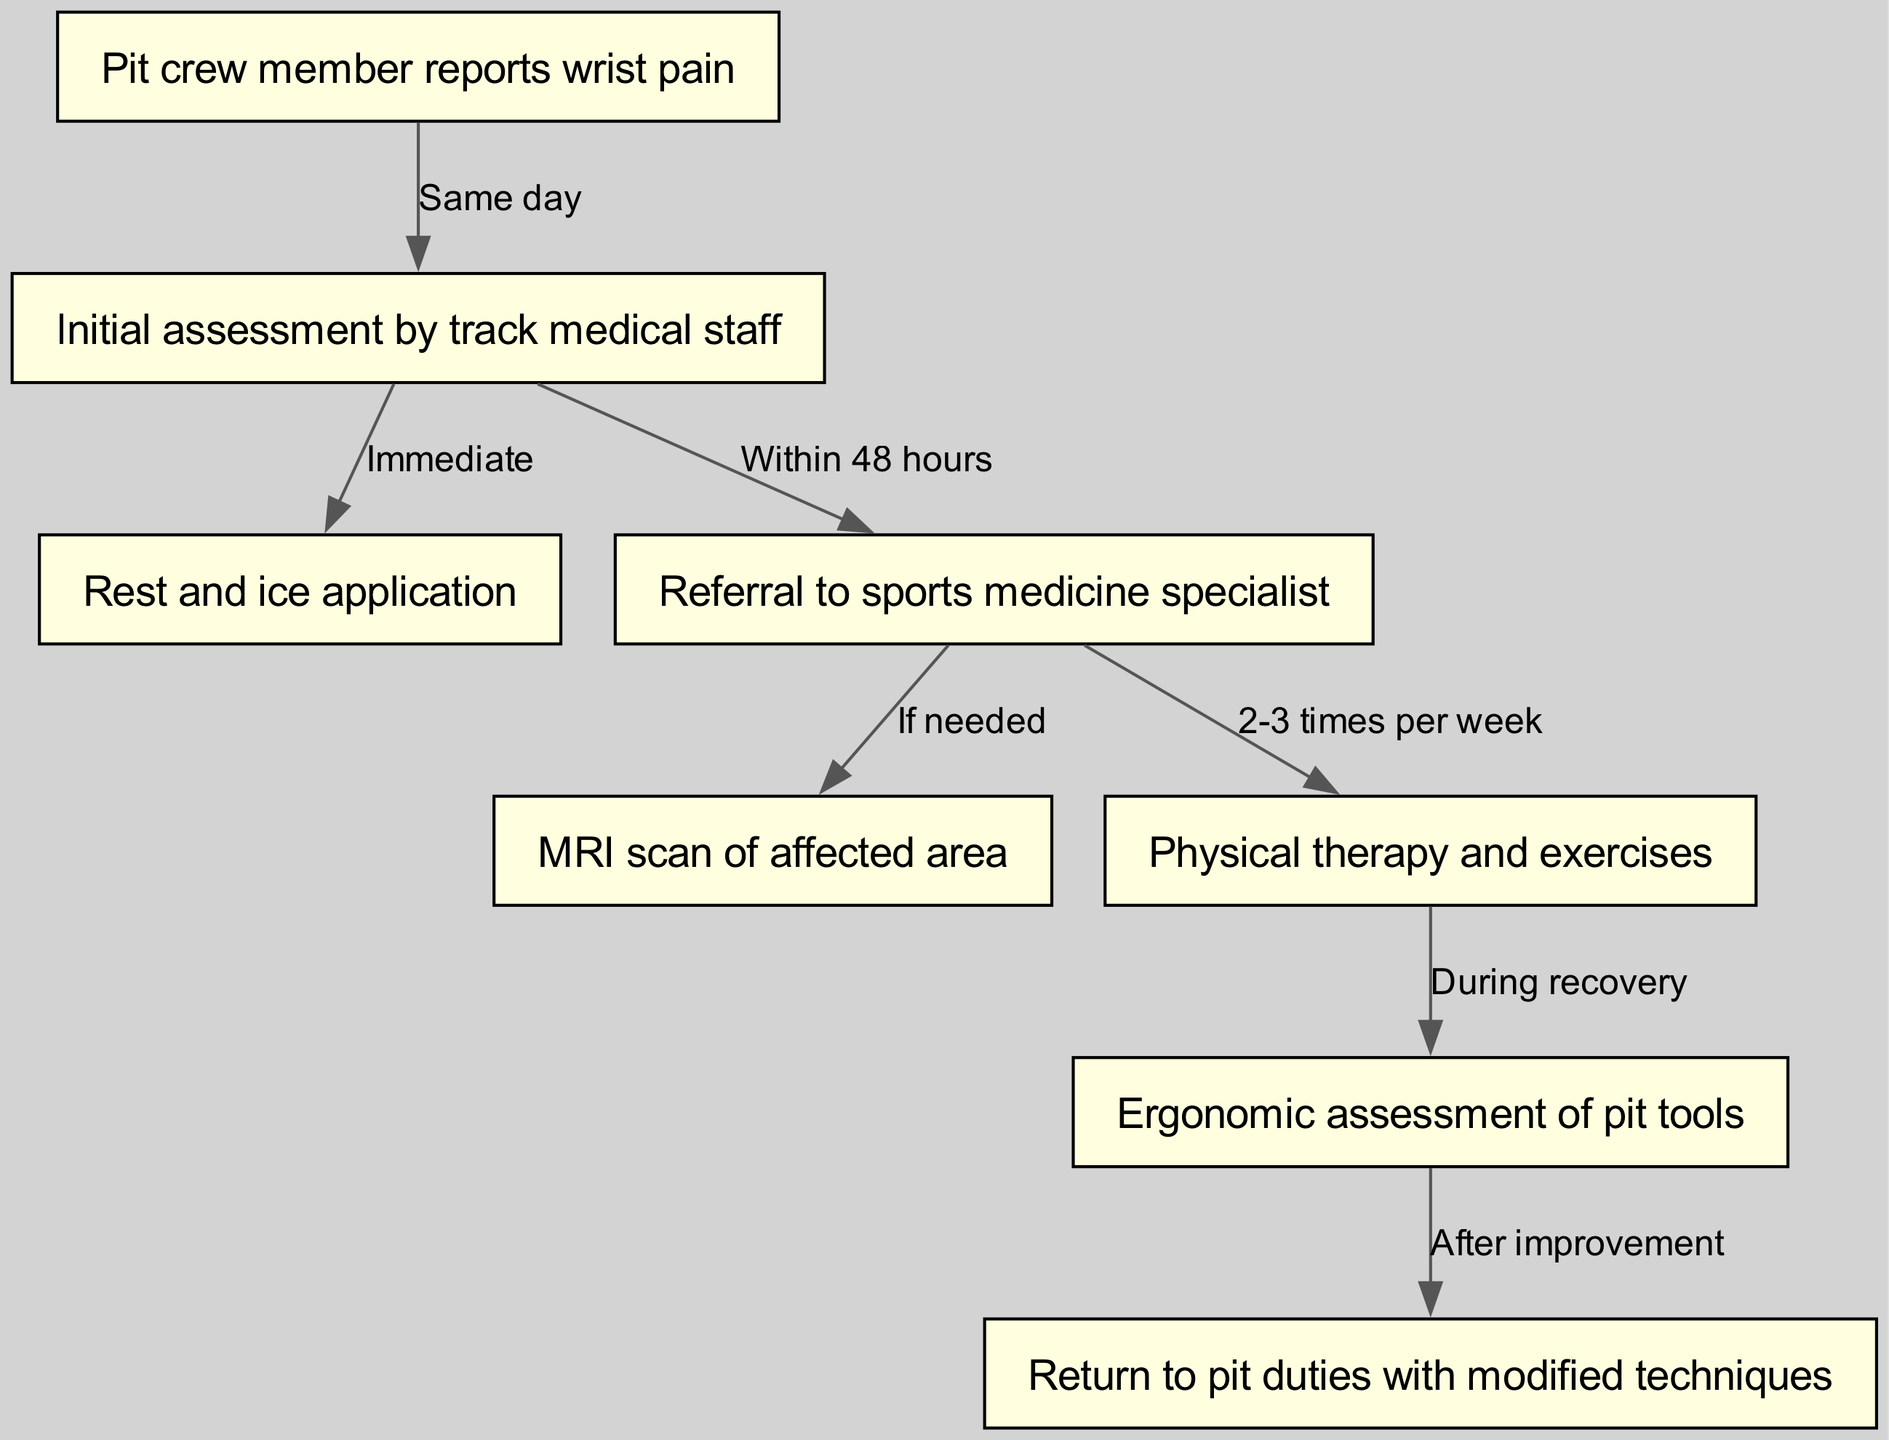What is the first step when a pit crew member reports pain? The first step according to the diagram is the "Initial assessment by track medical staff," which follows directly after the report of wrist pain.
Answer: Initial assessment by track medical staff How many nodes are present in the diagram? The total number of nodes can be counted as there are eight distinct steps listed, each representing a node.
Answer: 8 What action follows the initial assessment by track medical staff? The diagram indicates that the next action after the initial assessment is "Rest and ice application," which is connected directly to the assessment node.
Answer: Rest and ice application What is the frequency of physical therapy sessions recommended? The diagram states that physical therapy should occur "2-3 times per week," which is specified in the connection from the referral to the physical therapy node.
Answer: 2-3 times per week What step occurs after any improvement in the ergonomic assessment? The diagram shows that the "Return to pit duties with modified techniques" step follows the "Ergonomic assessment of pit tools" after improvement is noted.
Answer: Return to pit duties with modified techniques Which step requires an MRI scan? The step "MRI scan of affected area" is only necessary if indicated, as stated in the connection from the referral to the sports medicine specialist.
Answer: If needed What leads to the need for an ergonomic assessment? The diagram shows that an ergonomic assessment is conducted "During recovery," which follows after engaging in physical therapy and exercises.
Answer: During recovery How long after the initial assessment does a referral to a sports medicine specialist occur? The diagram specifies that the referral should take place "Within 48 hours" of the initial assessment by the medical staff.
Answer: Within 48 hours 